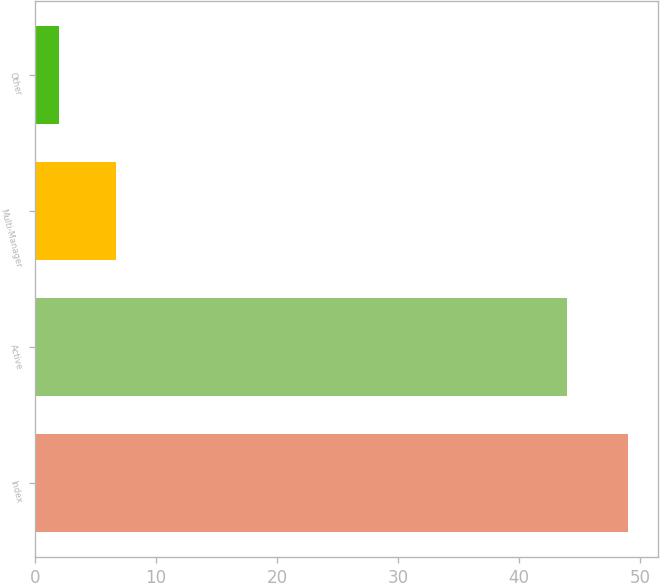Convert chart. <chart><loc_0><loc_0><loc_500><loc_500><bar_chart><fcel>Index<fcel>Active<fcel>Multi-Manager<fcel>Other<nl><fcel>49<fcel>44<fcel>6.7<fcel>2<nl></chart> 